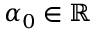<formula> <loc_0><loc_0><loc_500><loc_500>\alpha _ { 0 } \in \mathbb { R }</formula> 